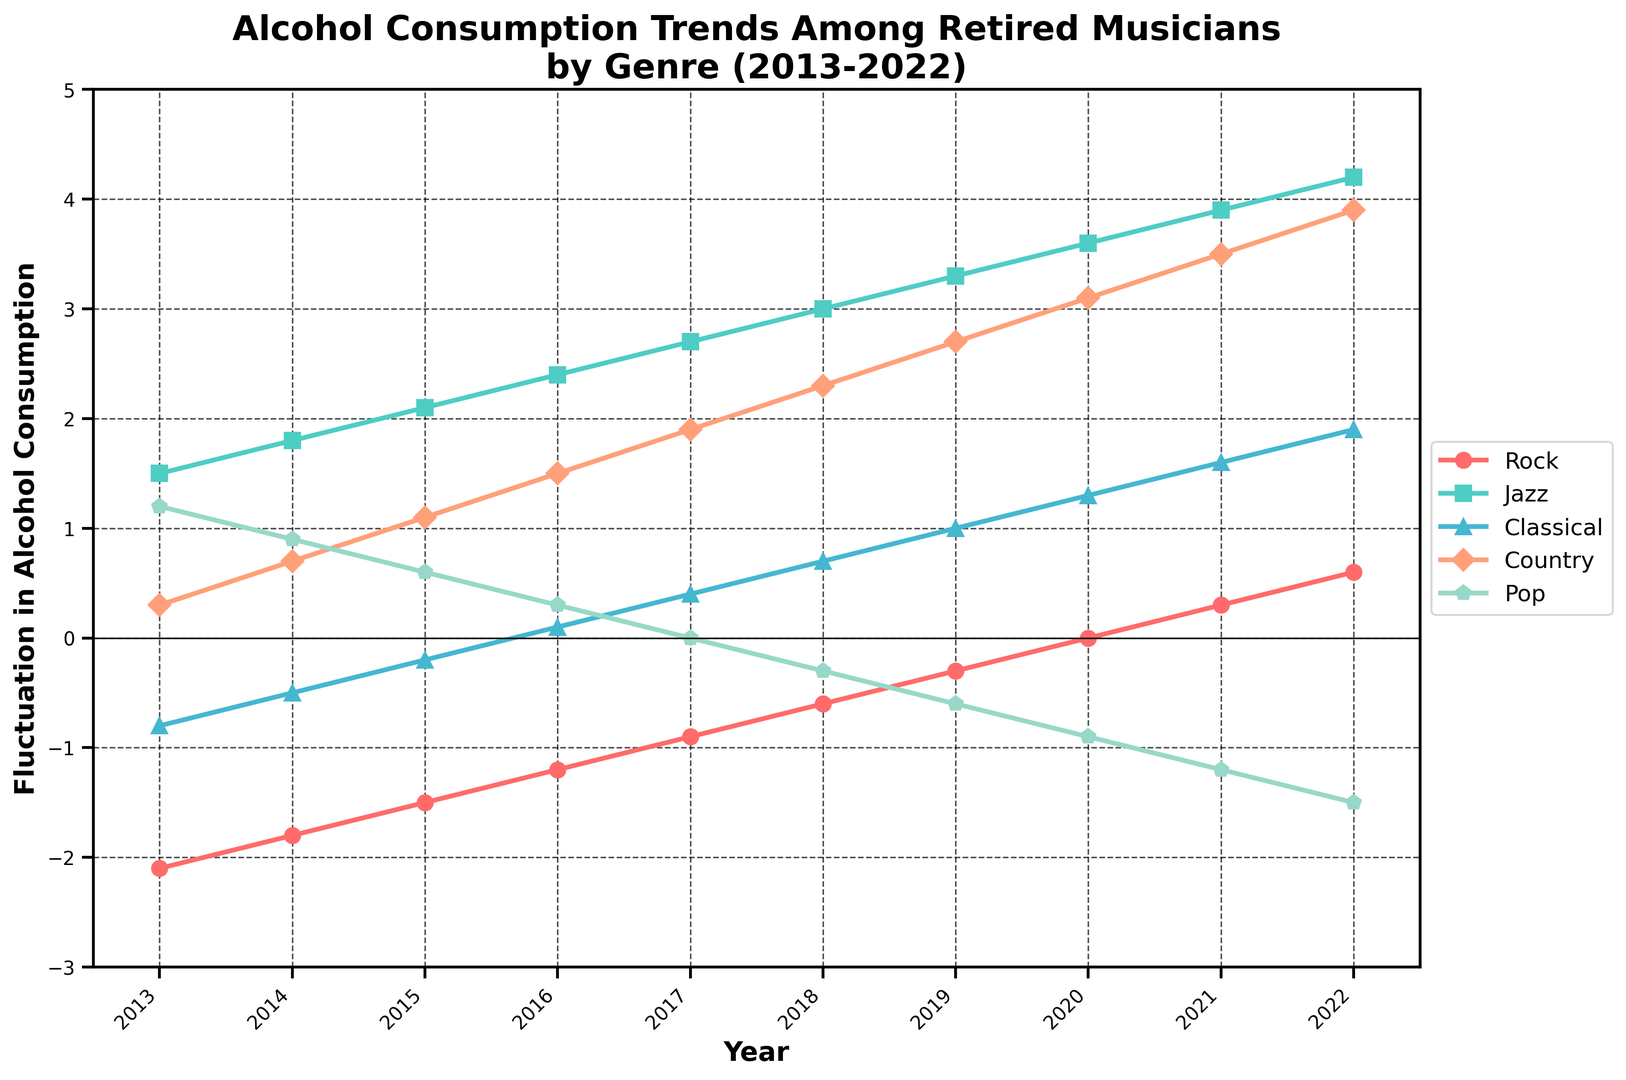Which genre showed the most significant increase in alcohol consumption from 2013 to 2022? To determine which genre showed the most significant increase, we need to look at the values for each genre in 2013 and 2022 and compute the difference. For Jazz: 4.2 - 1.5 = 2.7, for Rock: 0.6 - (-2.1) = 2.7, for Classical: 1.9 - (-0.8) = 2.7, for Country: 3.9 - 0.3 = 3.6, for Pop: -1.5 - 1.2 = -2.7. Country showed the most significant increase.
Answer: Country Which genre had a downward trend in alcohol consumption from 2013 to 2016? We need to check the values for each genre from 2013 to 2016 to identify any decreasing patterns. For Rock: -2.1 to -1.2 (upward), Jazz: 1.5 to 2.4 (upward), Classical: -0.8 to 0.1 (upward), Country: 0.3 to 1.5 (upward), Pop: 1.2 to 0.3 (downward). Only Pop showed a downward trend.
Answer: Pop In which year did Rock consumption hit zero? We look at the Rock genre's values over the years and identify the year when the value is zero. The value for Rock is zero in the year 2020.
Answer: 2020 What is the average fluctuation in alcohol consumption for Jazz from 2013 to 2022? We need to sum up the values for Jazz for each year from 2013 to 2022 and then divide by the number of years. Values for Jazz are 1.5, 1.8, 2.1, 2.4, 2.7, 3.0, 3.3, 3.6, 3.9, 4.2. Summing these gives 28.5. Dividing by 10, the average fluctuation is 2.85.
Answer: 2.85 In which year did Classical first show a positive fluctuation in consumption? We need to look at the year-by-year values for Classical and identify the first year with a positive value. Classical becomes positive in 2016 with a value of 0.1.
Answer: 2016 Compare the trends of consumption for Classical and Country from 2015 to 2020. For Classical, the values from 2015 to 2020 are -0.2, 0.1, 0.4, 0.7, 1.0, 1.3 (increasing trend). For Country, the values are 1.1, 1.5, 1.9, 2.3, 2.7, 3.1 (increasing trend). Both genres show an increasing trend during this period.
Answer: Increasing for both By how much did Pop consumption decrease from 2013 to 2022? We calculate the change in values for Pop from 2013 to 2022. For Pop: -1.5 - 1.2 = -2.7. Therefore, the decrease in Pop consumption is by 2.7 units.
Answer: -2.7 Which genre has the highest consumption fluctuation in 2022? We check the values for each genre in 2022. Values are Rock: 0.6, Jazz: 4.2, Classical: 1.9, Country: 3.9, Pop: -1.5. Jazz has the highest fluctuation in 2022.
Answer: Jazz 